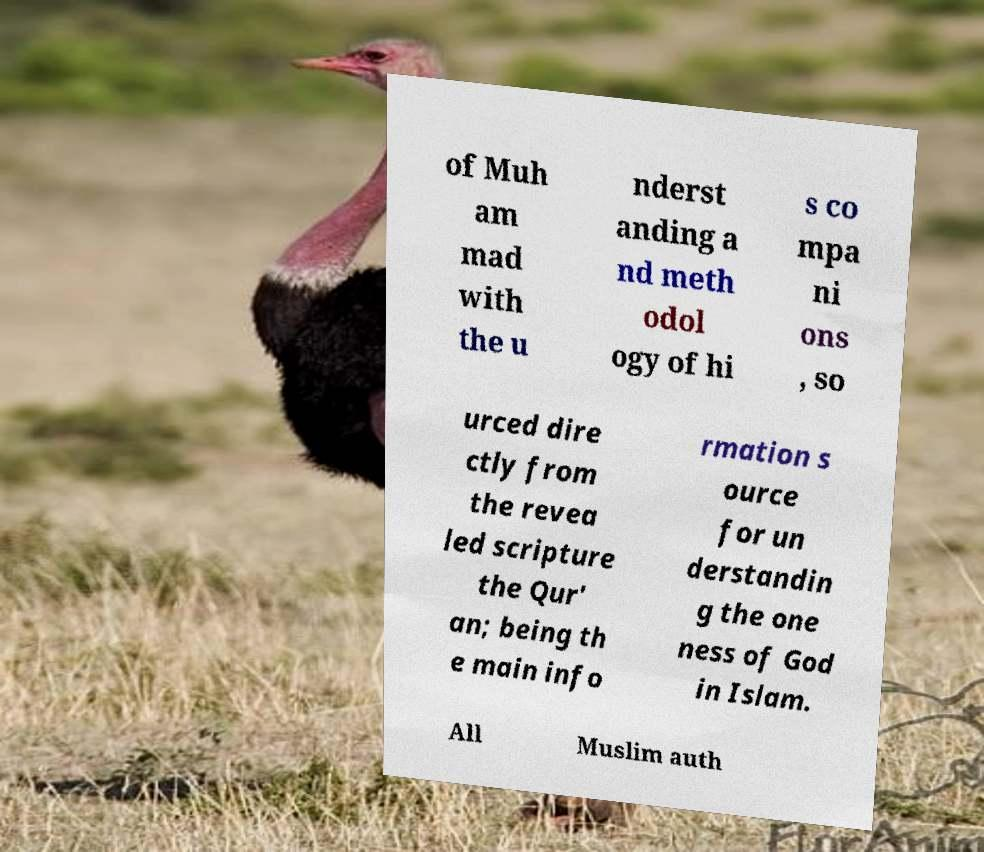Could you assist in decoding the text presented in this image and type it out clearly? of Muh am mad with the u nderst anding a nd meth odol ogy of hi s co mpa ni ons , so urced dire ctly from the revea led scripture the Qur' an; being th e main info rmation s ource for un derstandin g the one ness of God in Islam. All Muslim auth 